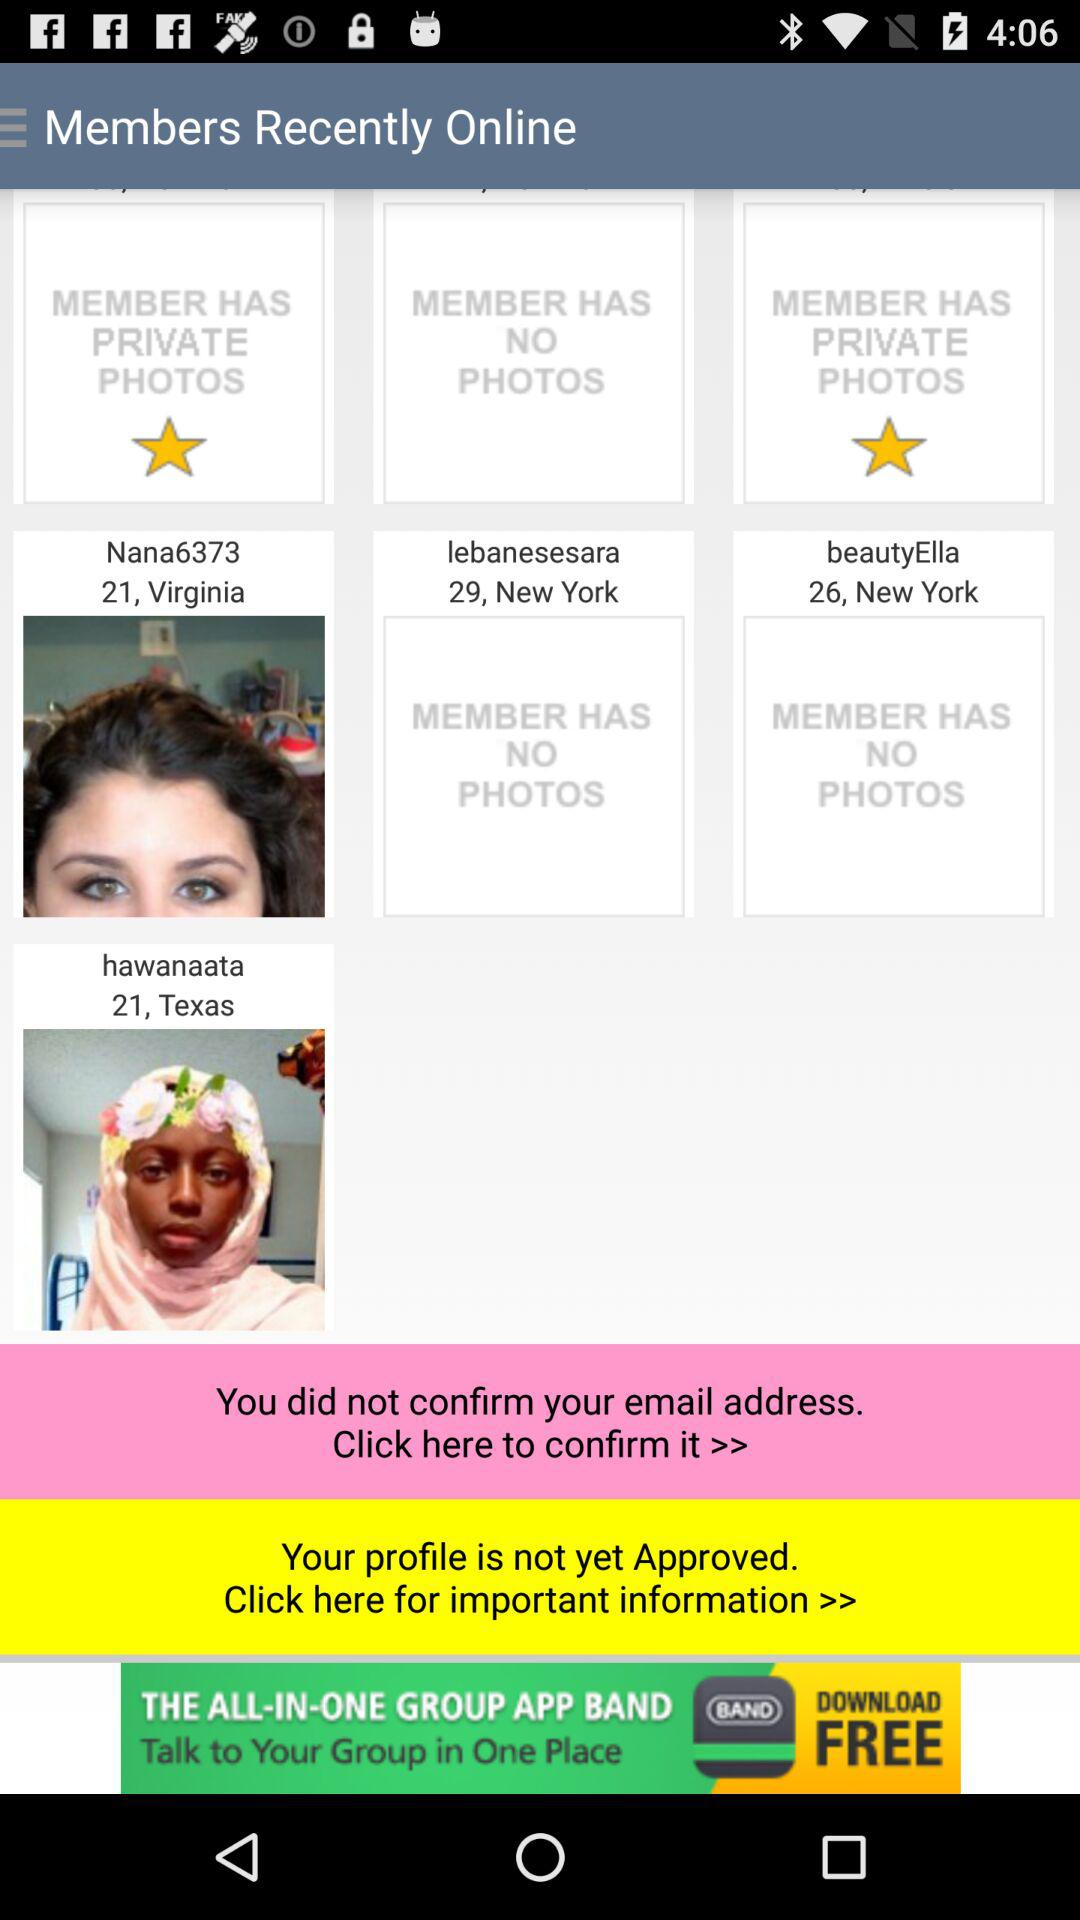In what city does Nana6373 live? Nana6373 lives in Virginia. 